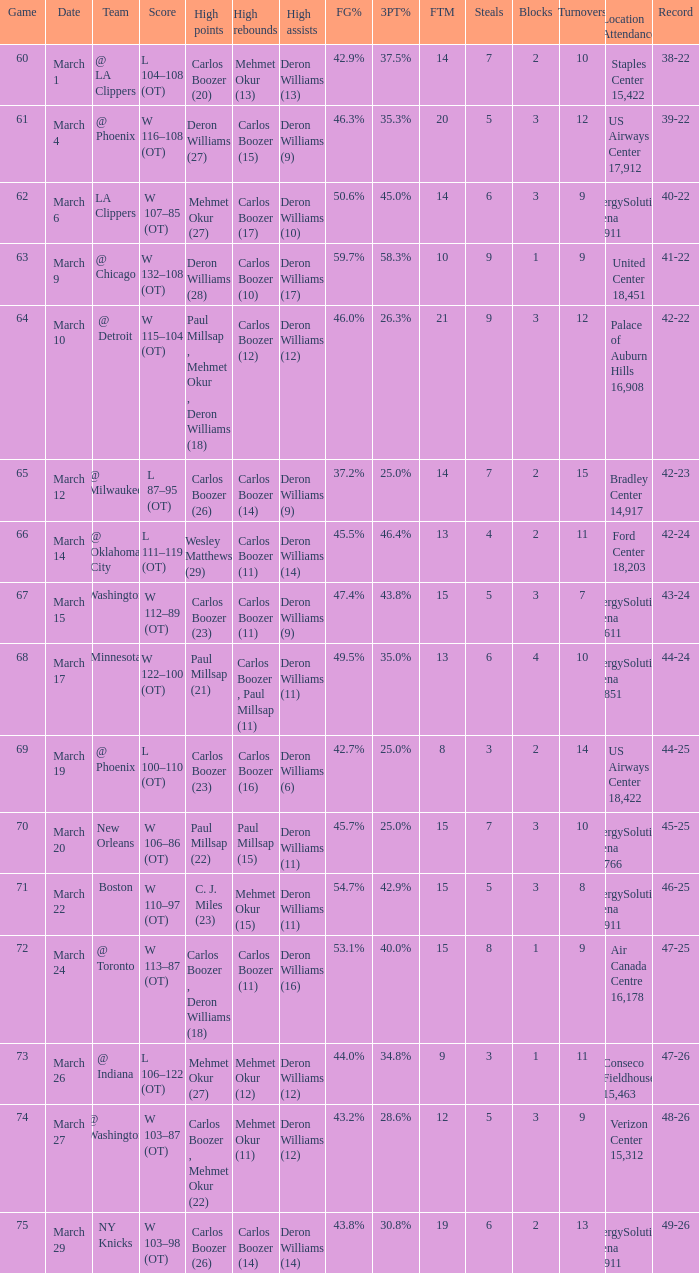How many different players did the most high assists on the March 4 game? 1.0. Could you parse the entire table? {'header': ['Game', 'Date', 'Team', 'Score', 'High points', 'High rebounds', 'High assists', 'FG%', '3PT%', 'FTM', 'Steals', 'Blocks', 'Turnovers', 'Location Attendance', 'Record'], 'rows': [['60', 'March 1', '@ LA Clippers', 'L 104–108 (OT)', 'Carlos Boozer (20)', 'Mehmet Okur (13)', 'Deron Williams (13)', '42.9%', '37.5%', '14', '7', '2', '10', 'Staples Center 15,422', '38-22'], ['61', 'March 4', '@ Phoenix', 'W 116–108 (OT)', 'Deron Williams (27)', 'Carlos Boozer (15)', 'Deron Williams (9)', '46.3%', '35.3%', '20', '5', '3', '12', 'US Airways Center 17,912', '39-22'], ['62', 'March 6', 'LA Clippers', 'W 107–85 (OT)', 'Mehmet Okur (27)', 'Carlos Boozer (17)', 'Deron Williams (10)', '50.6%', '45.0%', '14', '6', '3', '9', 'EnergySolutions Arena 19,911', '40-22'], ['63', 'March 9', '@ Chicago', 'W 132–108 (OT)', 'Deron Williams (28)', 'Carlos Boozer (10)', 'Deron Williams (17)', '59.7%', '58.3%', '10', '9', '1', '9', 'United Center 18,451', '41-22'], ['64', 'March 10', '@ Detroit', 'W 115–104 (OT)', 'Paul Millsap , Mehmet Okur , Deron Williams (18)', 'Carlos Boozer (12)', 'Deron Williams (12)', '46.0%', '26.3%', '21', '9', '3', '12', 'Palace of Auburn Hills 16,908', '42-22'], ['65', 'March 12', '@ Milwaukee', 'L 87–95 (OT)', 'Carlos Boozer (26)', 'Carlos Boozer (14)', 'Deron Williams (9)', '37.2%', '25.0%', '14', '7', '2', '15', 'Bradley Center 14,917', '42-23'], ['66', 'March 14', '@ Oklahoma City', 'L 111–119 (OT)', 'Wesley Matthews (29)', 'Carlos Boozer (11)', 'Deron Williams (14)', '45.5%', '46.4%', '13', '4', '2', '11', 'Ford Center 18,203', '42-24'], ['67', 'March 15', 'Washington', 'W 112–89 (OT)', 'Carlos Boozer (23)', 'Carlos Boozer (11)', 'Deron Williams (9)', '47.4%', '43.8%', '15', '5', '3', '7', 'EnergySolutions Arena 19,611', '43-24'], ['68', 'March 17', 'Minnesota', 'W 122–100 (OT)', 'Paul Millsap (21)', 'Carlos Boozer , Paul Millsap (11)', 'Deron Williams (11)', '49.5%', '35.0%', '13', '6', '4', '10', 'EnergySolutions Arena 19,851', '44-24'], ['69', 'March 19', '@ Phoenix', 'L 100–110 (OT)', 'Carlos Boozer (23)', 'Carlos Boozer (16)', 'Deron Williams (6)', '42.7%', '25.0%', '8', '3', '2', '14', 'US Airways Center 18,422', '44-25'], ['70', 'March 20', 'New Orleans', 'W 106–86 (OT)', 'Paul Millsap (22)', 'Paul Millsap (15)', 'Deron Williams (11)', '45.7%', '25.0%', '15', '7', '3', '10', 'EnergySolutions Arena 18,766', '45-25'], ['71', 'March 22', 'Boston', 'W 110–97 (OT)', 'C. J. Miles (23)', 'Mehmet Okur (15)', 'Deron Williams (11)', '54.7%', '42.9%', '15', '5', '3', '8', 'EnergySolutions Arena 19,911', '46-25'], ['72', 'March 24', '@ Toronto', 'W 113–87 (OT)', 'Carlos Boozer , Deron Williams (18)', 'Carlos Boozer (11)', 'Deron Williams (16)', '53.1%', '40.0%', '15', '8', '1', '9', 'Air Canada Centre 16,178', '47-25'], ['73', 'March 26', '@ Indiana', 'L 106–122 (OT)', 'Mehmet Okur (27)', 'Mehmet Okur (12)', 'Deron Williams (12)', '44.0%', '34.8%', '9', '3', '1', '11', 'Conseco Fieldhouse 15,463', '47-26'], ['74', 'March 27', '@ Washington', 'W 103–87 (OT)', 'Carlos Boozer , Mehmet Okur (22)', 'Mehmet Okur (11)', 'Deron Williams (12)', '43.2%', '28.6%', '12', '5', '3', '9', 'Verizon Center 15,312', '48-26'], ['75', 'March 29', 'NY Knicks', 'W 103–98 (OT)', 'Carlos Boozer (26)', 'Carlos Boozer (14)', 'Deron Williams (14)', '43.8%', '30.8%', '19', '6', '2', '13', 'EnergySolutions Arena 19,911', '49-26']]} 